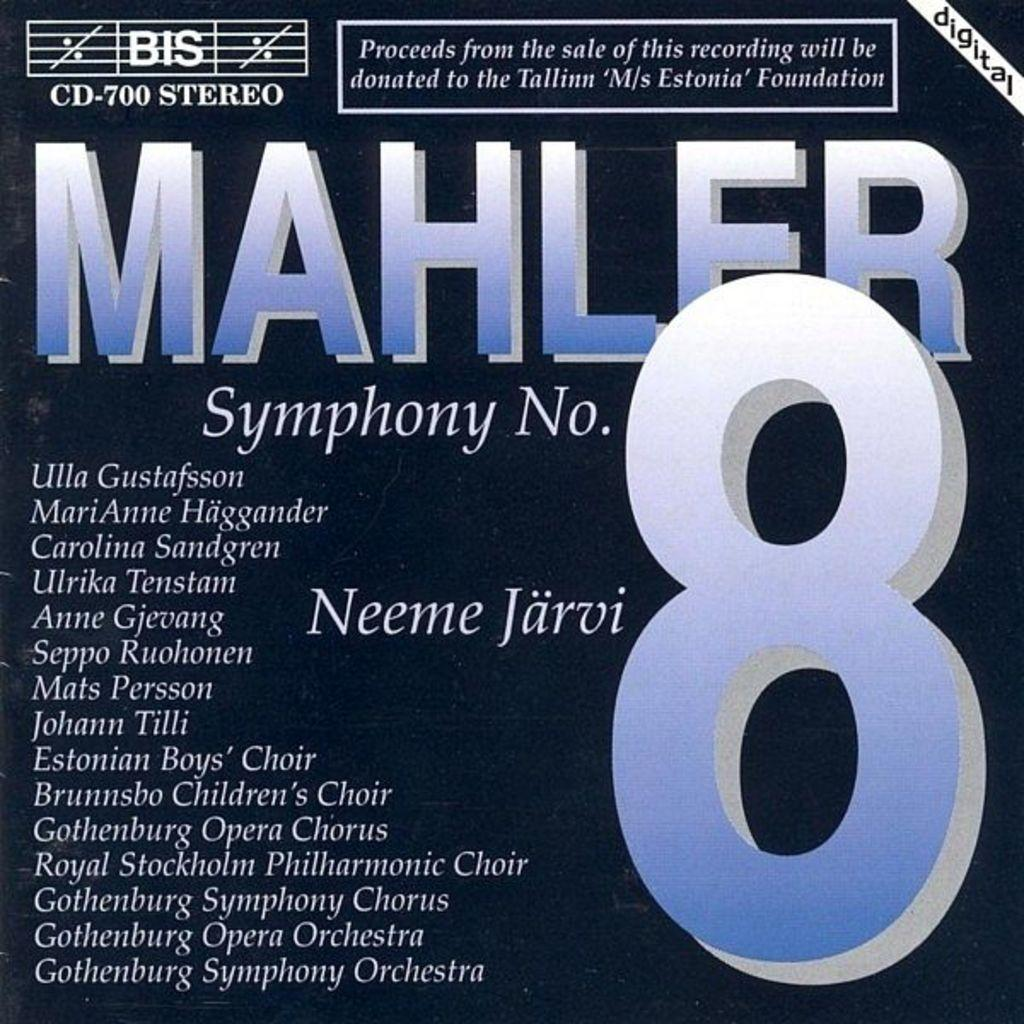<image>
Offer a succinct explanation of the picture presented. a symphony with the number 8 on it 